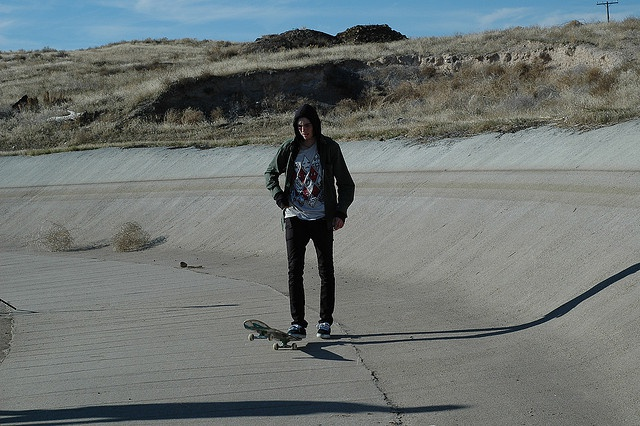Describe the objects in this image and their specific colors. I can see people in gray, black, darkgray, and navy tones and skateboard in gray, black, darkgray, and purple tones in this image. 